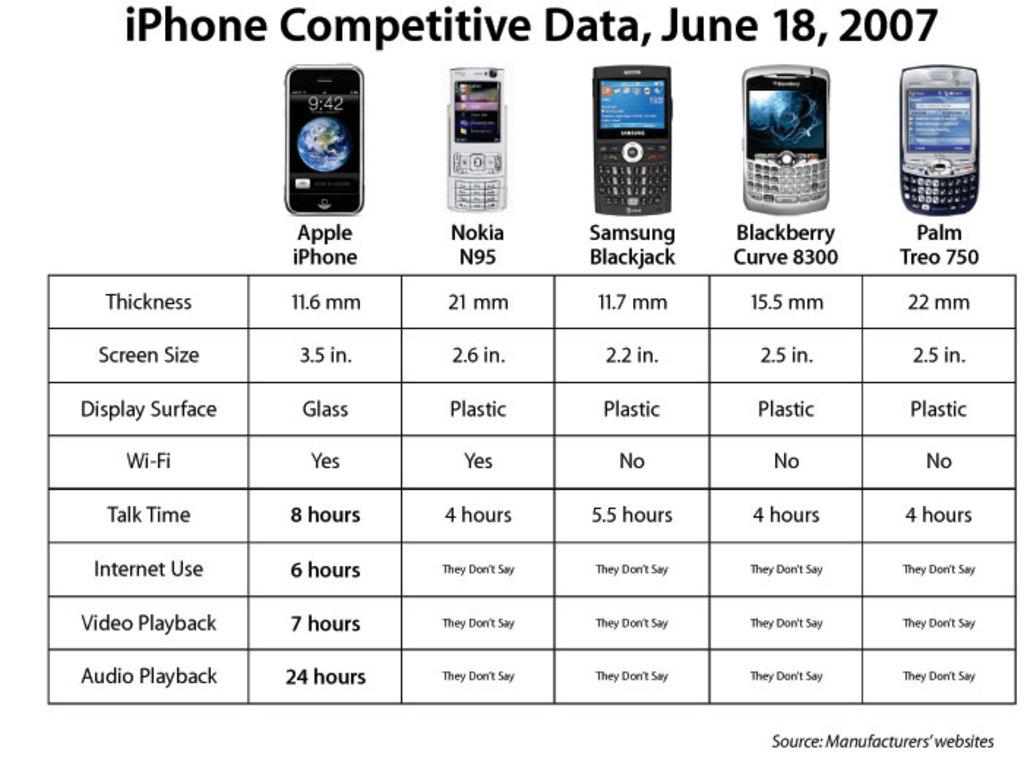How many hours of video playback does the iphone have?
Provide a short and direct response. 7. What model is the iphone phone?
Provide a succinct answer. Apple. 